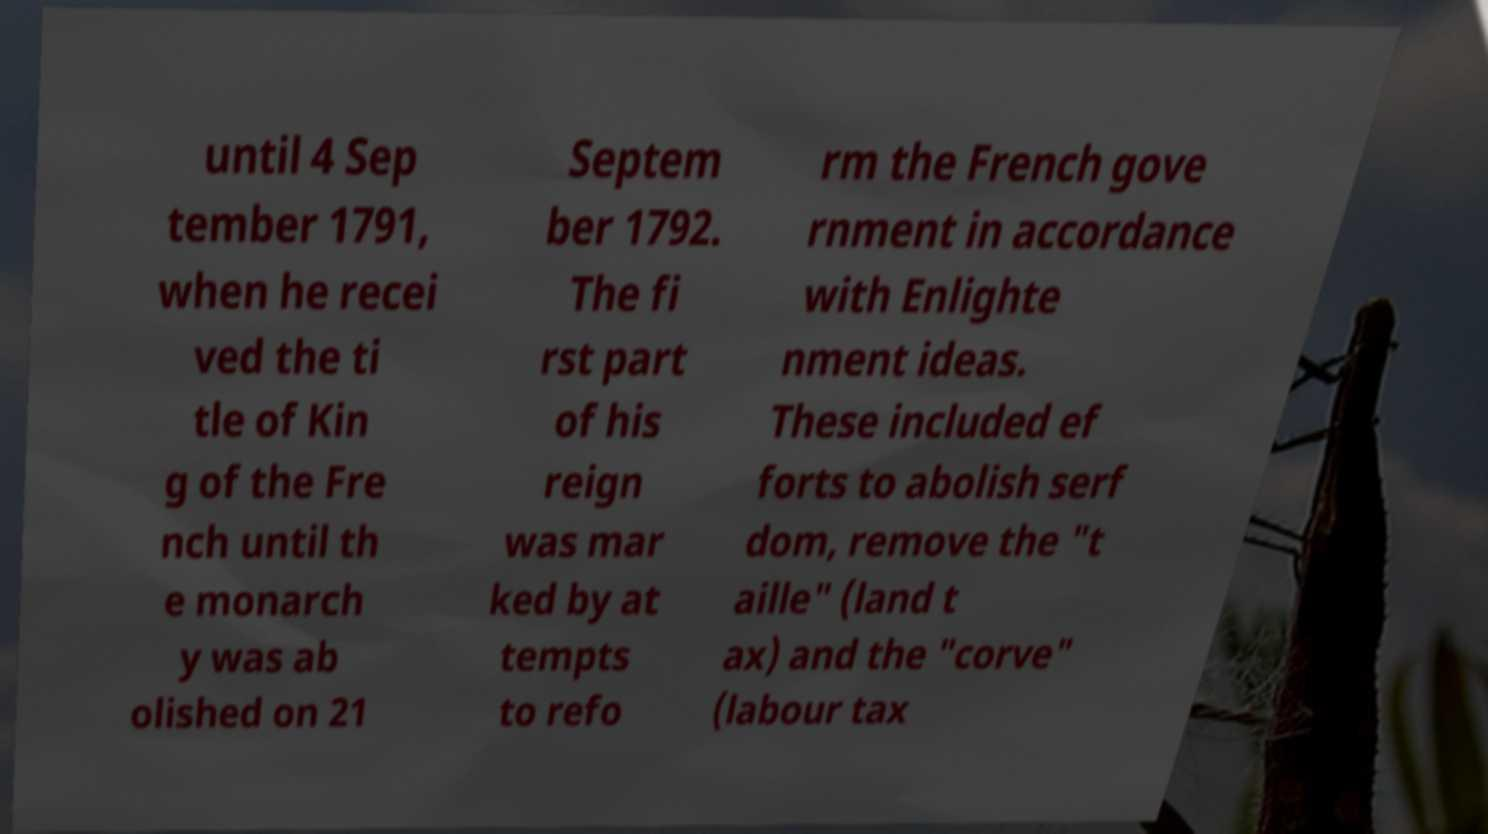Please identify and transcribe the text found in this image. until 4 Sep tember 1791, when he recei ved the ti tle of Kin g of the Fre nch until th e monarch y was ab olished on 21 Septem ber 1792. The fi rst part of his reign was mar ked by at tempts to refo rm the French gove rnment in accordance with Enlighte nment ideas. These included ef forts to abolish serf dom, remove the "t aille" (land t ax) and the "corve" (labour tax 